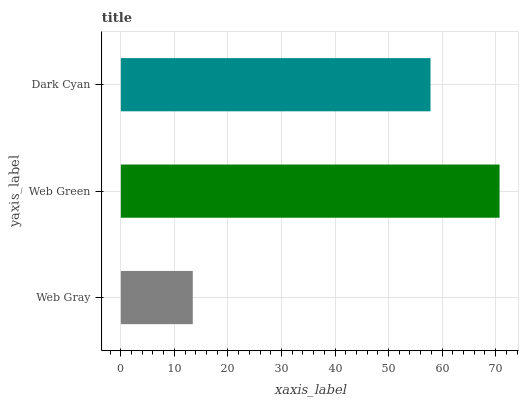Is Web Gray the minimum?
Answer yes or no. Yes. Is Web Green the maximum?
Answer yes or no. Yes. Is Dark Cyan the minimum?
Answer yes or no. No. Is Dark Cyan the maximum?
Answer yes or no. No. Is Web Green greater than Dark Cyan?
Answer yes or no. Yes. Is Dark Cyan less than Web Green?
Answer yes or no. Yes. Is Dark Cyan greater than Web Green?
Answer yes or no. No. Is Web Green less than Dark Cyan?
Answer yes or no. No. Is Dark Cyan the high median?
Answer yes or no. Yes. Is Dark Cyan the low median?
Answer yes or no. Yes. Is Web Green the high median?
Answer yes or no. No. Is Web Green the low median?
Answer yes or no. No. 